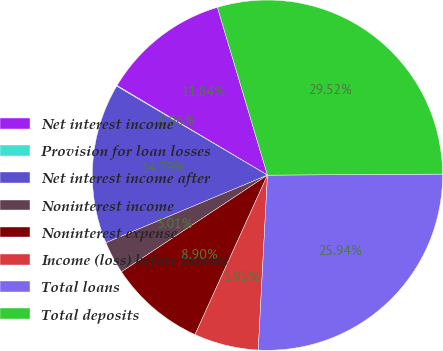Convert chart. <chart><loc_0><loc_0><loc_500><loc_500><pie_chart><fcel>Net interest income<fcel>Provision for loan losses<fcel>Net interest income after<fcel>Noninterest income<fcel>Noninterest expense<fcel>Income (loss) before income<fcel>Total loans<fcel>Total deposits<nl><fcel>11.84%<fcel>0.06%<fcel>14.79%<fcel>3.01%<fcel>8.9%<fcel>5.95%<fcel>25.94%<fcel>29.52%<nl></chart> 